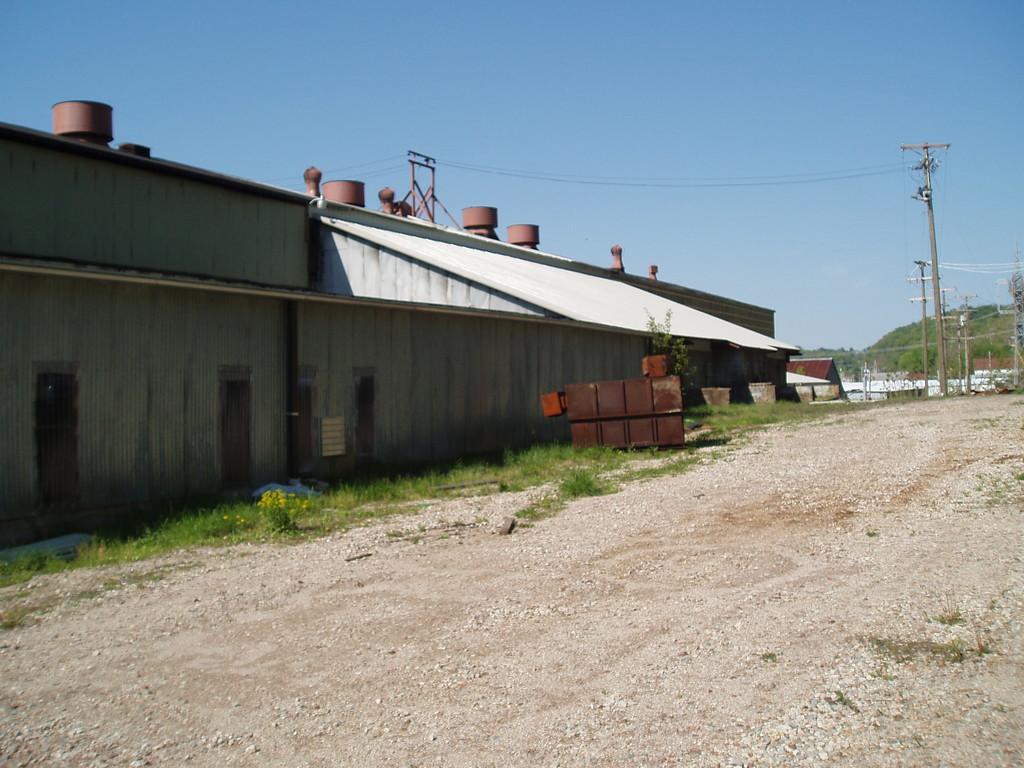In one or two sentences, can you explain what this image depicts? In this picture we can see the ground, plants, buildings, poles, wires, mountain, some objects and in the background we can see the sky. 